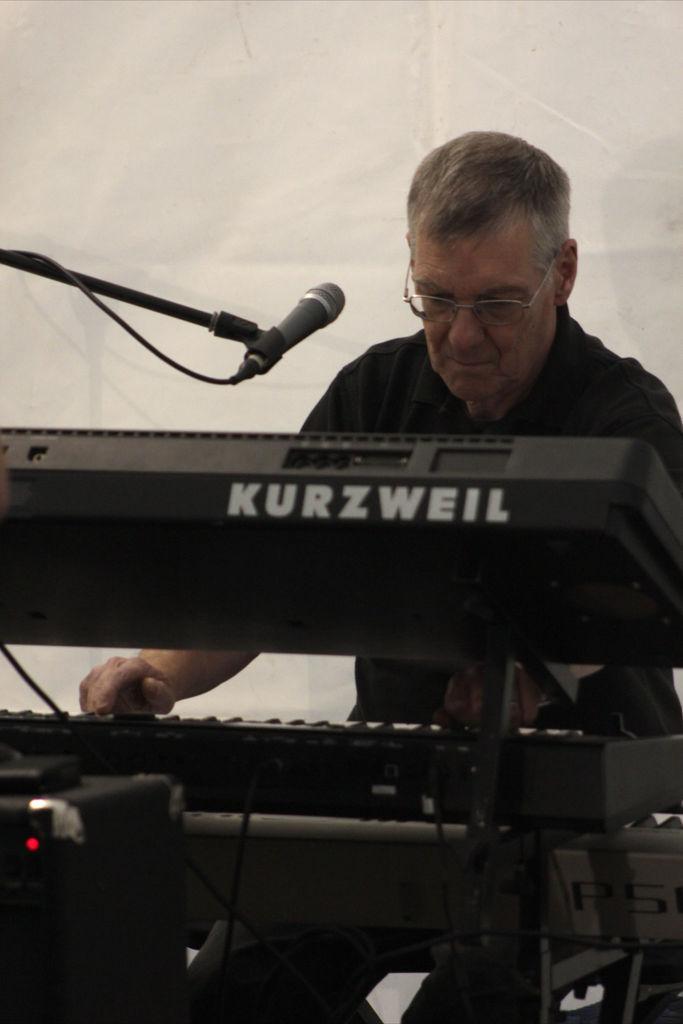How would you summarize this image in a sentence or two? In this picture there is a person playing musical instruments. On the left there is a microphone. At the bottom there is a musical control system and there are cables. In the background it is a wall. 